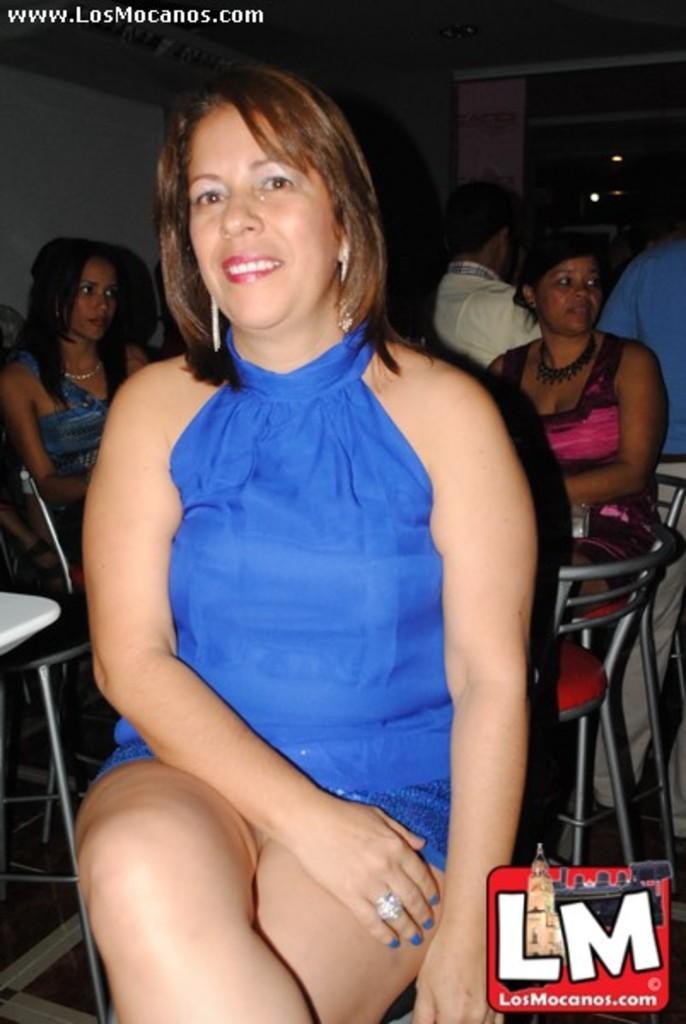Please provide a concise description of this image. Here I can see a woman sitting on the chair, wearing a blue color dress, smiling and giving pose for the picture. In the background, I can see some people are sitting on the chairs. This is an inside view. At the bottom right, I can see a logo. 